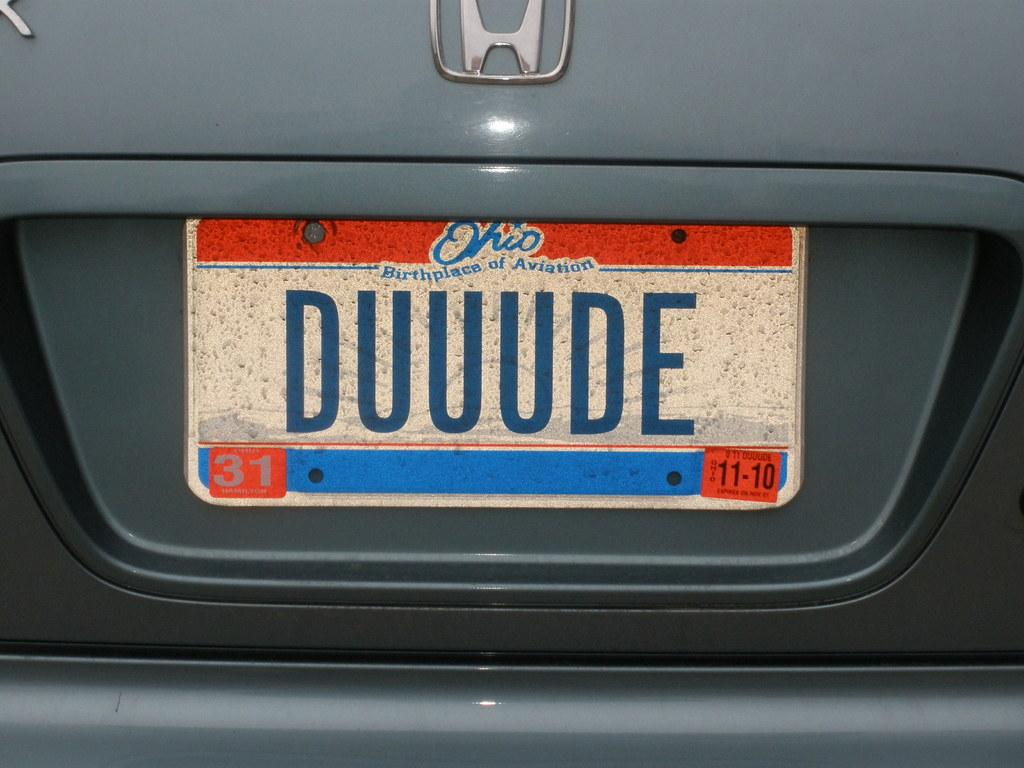<image>
Summarize the visual content of the image. A license plate on a car of someone who moved to Ohio from the L.A. valley. 